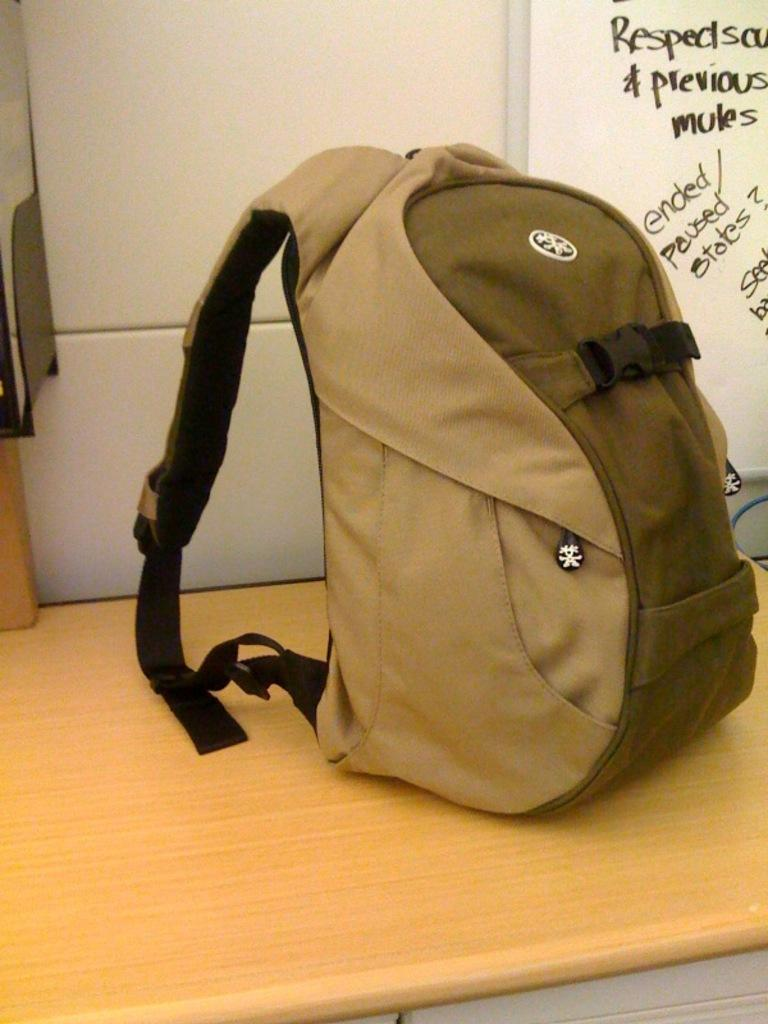Provide a one-sentence caption for the provided image. A backpack sits in front of a whiteboard that has information about mules on it. 